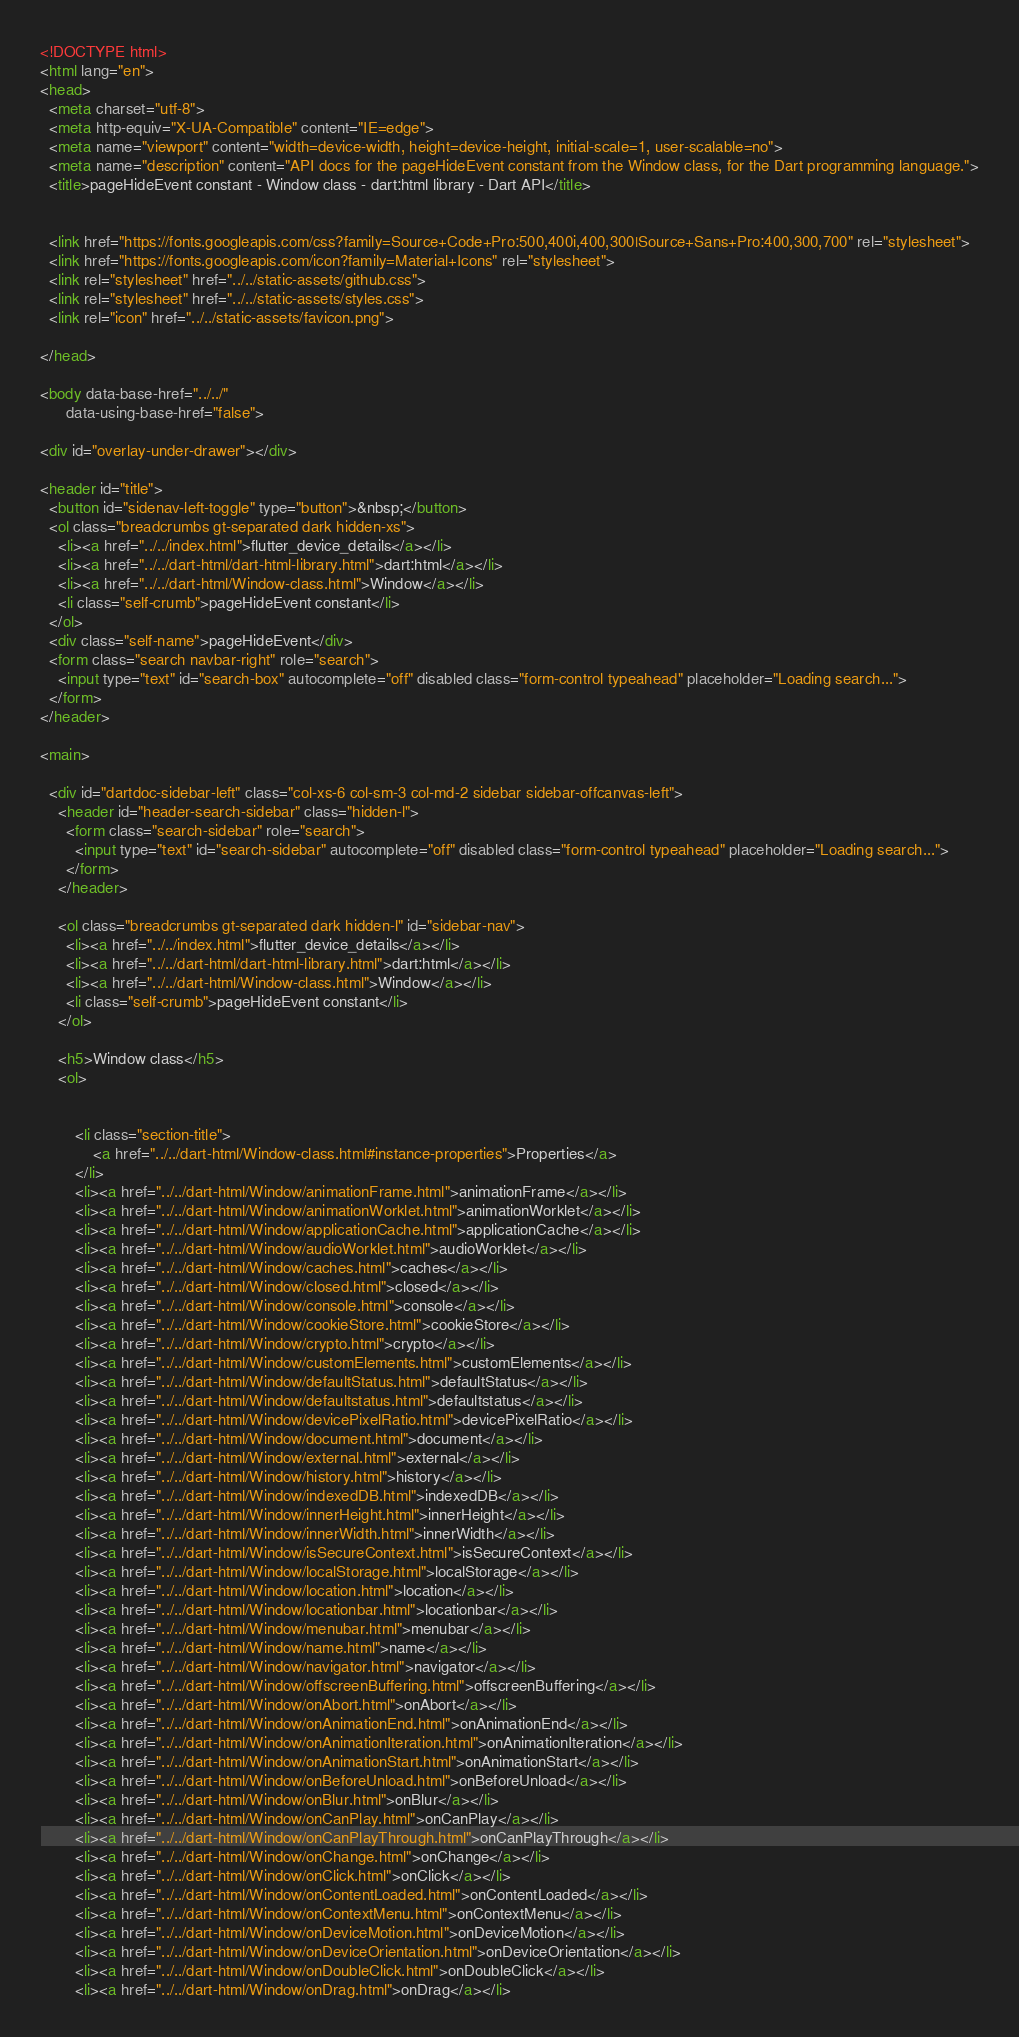Convert code to text. <code><loc_0><loc_0><loc_500><loc_500><_HTML_><!DOCTYPE html>
<html lang="en">
<head>
  <meta charset="utf-8">
  <meta http-equiv="X-UA-Compatible" content="IE=edge">
  <meta name="viewport" content="width=device-width, height=device-height, initial-scale=1, user-scalable=no">
  <meta name="description" content="API docs for the pageHideEvent constant from the Window class, for the Dart programming language.">
  <title>pageHideEvent constant - Window class - dart:html library - Dart API</title>

  
  <link href="https://fonts.googleapis.com/css?family=Source+Code+Pro:500,400i,400,300|Source+Sans+Pro:400,300,700" rel="stylesheet">
  <link href="https://fonts.googleapis.com/icon?family=Material+Icons" rel="stylesheet">
  <link rel="stylesheet" href="../../static-assets/github.css">
  <link rel="stylesheet" href="../../static-assets/styles.css">
  <link rel="icon" href="../../static-assets/favicon.png">

</head>

<body data-base-href="../../"
      data-using-base-href="false">

<div id="overlay-under-drawer"></div>

<header id="title">
  <button id="sidenav-left-toggle" type="button">&nbsp;</button>
  <ol class="breadcrumbs gt-separated dark hidden-xs">
    <li><a href="../../index.html">flutter_device_details</a></li>
    <li><a href="../../dart-html/dart-html-library.html">dart:html</a></li>
    <li><a href="../../dart-html/Window-class.html">Window</a></li>
    <li class="self-crumb">pageHideEvent constant</li>
  </ol>
  <div class="self-name">pageHideEvent</div>
  <form class="search navbar-right" role="search">
    <input type="text" id="search-box" autocomplete="off" disabled class="form-control typeahead" placeholder="Loading search...">
  </form>
</header>

<main>

  <div id="dartdoc-sidebar-left" class="col-xs-6 col-sm-3 col-md-2 sidebar sidebar-offcanvas-left">
    <header id="header-search-sidebar" class="hidden-l">
      <form class="search-sidebar" role="search">
        <input type="text" id="search-sidebar" autocomplete="off" disabled class="form-control typeahead" placeholder="Loading search...">
      </form>
    </header>
    
    <ol class="breadcrumbs gt-separated dark hidden-l" id="sidebar-nav">
      <li><a href="../../index.html">flutter_device_details</a></li>
      <li><a href="../../dart-html/dart-html-library.html">dart:html</a></li>
      <li><a href="../../dart-html/Window-class.html">Window</a></li>
      <li class="self-crumb">pageHideEvent constant</li>
    </ol>
    
    <h5>Window class</h5>
    <ol>
    
    
        <li class="section-title">
            <a href="../../dart-html/Window-class.html#instance-properties">Properties</a>
        </li>
        <li><a href="../../dart-html/Window/animationFrame.html">animationFrame</a></li>
        <li><a href="../../dart-html/Window/animationWorklet.html">animationWorklet</a></li>
        <li><a href="../../dart-html/Window/applicationCache.html">applicationCache</a></li>
        <li><a href="../../dart-html/Window/audioWorklet.html">audioWorklet</a></li>
        <li><a href="../../dart-html/Window/caches.html">caches</a></li>
        <li><a href="../../dart-html/Window/closed.html">closed</a></li>
        <li><a href="../../dart-html/Window/console.html">console</a></li>
        <li><a href="../../dart-html/Window/cookieStore.html">cookieStore</a></li>
        <li><a href="../../dart-html/Window/crypto.html">crypto</a></li>
        <li><a href="../../dart-html/Window/customElements.html">customElements</a></li>
        <li><a href="../../dart-html/Window/defaultStatus.html">defaultStatus</a></li>
        <li><a href="../../dart-html/Window/defaultstatus.html">defaultstatus</a></li>
        <li><a href="../../dart-html/Window/devicePixelRatio.html">devicePixelRatio</a></li>
        <li><a href="../../dart-html/Window/document.html">document</a></li>
        <li><a href="../../dart-html/Window/external.html">external</a></li>
        <li><a href="../../dart-html/Window/history.html">history</a></li>
        <li><a href="../../dart-html/Window/indexedDB.html">indexedDB</a></li>
        <li><a href="../../dart-html/Window/innerHeight.html">innerHeight</a></li>
        <li><a href="../../dart-html/Window/innerWidth.html">innerWidth</a></li>
        <li><a href="../../dart-html/Window/isSecureContext.html">isSecureContext</a></li>
        <li><a href="../../dart-html/Window/localStorage.html">localStorage</a></li>
        <li><a href="../../dart-html/Window/location.html">location</a></li>
        <li><a href="../../dart-html/Window/locationbar.html">locationbar</a></li>
        <li><a href="../../dart-html/Window/menubar.html">menubar</a></li>
        <li><a href="../../dart-html/Window/name.html">name</a></li>
        <li><a href="../../dart-html/Window/navigator.html">navigator</a></li>
        <li><a href="../../dart-html/Window/offscreenBuffering.html">offscreenBuffering</a></li>
        <li><a href="../../dart-html/Window/onAbort.html">onAbort</a></li>
        <li><a href="../../dart-html/Window/onAnimationEnd.html">onAnimationEnd</a></li>
        <li><a href="../../dart-html/Window/onAnimationIteration.html">onAnimationIteration</a></li>
        <li><a href="../../dart-html/Window/onAnimationStart.html">onAnimationStart</a></li>
        <li><a href="../../dart-html/Window/onBeforeUnload.html">onBeforeUnload</a></li>
        <li><a href="../../dart-html/Window/onBlur.html">onBlur</a></li>
        <li><a href="../../dart-html/Window/onCanPlay.html">onCanPlay</a></li>
        <li><a href="../../dart-html/Window/onCanPlayThrough.html">onCanPlayThrough</a></li>
        <li><a href="../../dart-html/Window/onChange.html">onChange</a></li>
        <li><a href="../../dart-html/Window/onClick.html">onClick</a></li>
        <li><a href="../../dart-html/Window/onContentLoaded.html">onContentLoaded</a></li>
        <li><a href="../../dart-html/Window/onContextMenu.html">onContextMenu</a></li>
        <li><a href="../../dart-html/Window/onDeviceMotion.html">onDeviceMotion</a></li>
        <li><a href="../../dart-html/Window/onDeviceOrientation.html">onDeviceOrientation</a></li>
        <li><a href="../../dart-html/Window/onDoubleClick.html">onDoubleClick</a></li>
        <li><a href="../../dart-html/Window/onDrag.html">onDrag</a></li></code> 